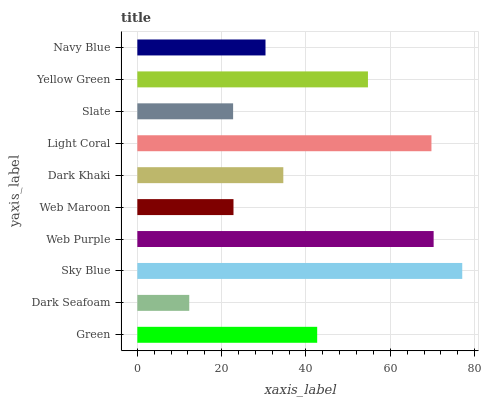Is Dark Seafoam the minimum?
Answer yes or no. Yes. Is Sky Blue the maximum?
Answer yes or no. Yes. Is Sky Blue the minimum?
Answer yes or no. No. Is Dark Seafoam the maximum?
Answer yes or no. No. Is Sky Blue greater than Dark Seafoam?
Answer yes or no. Yes. Is Dark Seafoam less than Sky Blue?
Answer yes or no. Yes. Is Dark Seafoam greater than Sky Blue?
Answer yes or no. No. Is Sky Blue less than Dark Seafoam?
Answer yes or no. No. Is Green the high median?
Answer yes or no. Yes. Is Dark Khaki the low median?
Answer yes or no. Yes. Is Light Coral the high median?
Answer yes or no. No. Is Green the low median?
Answer yes or no. No. 